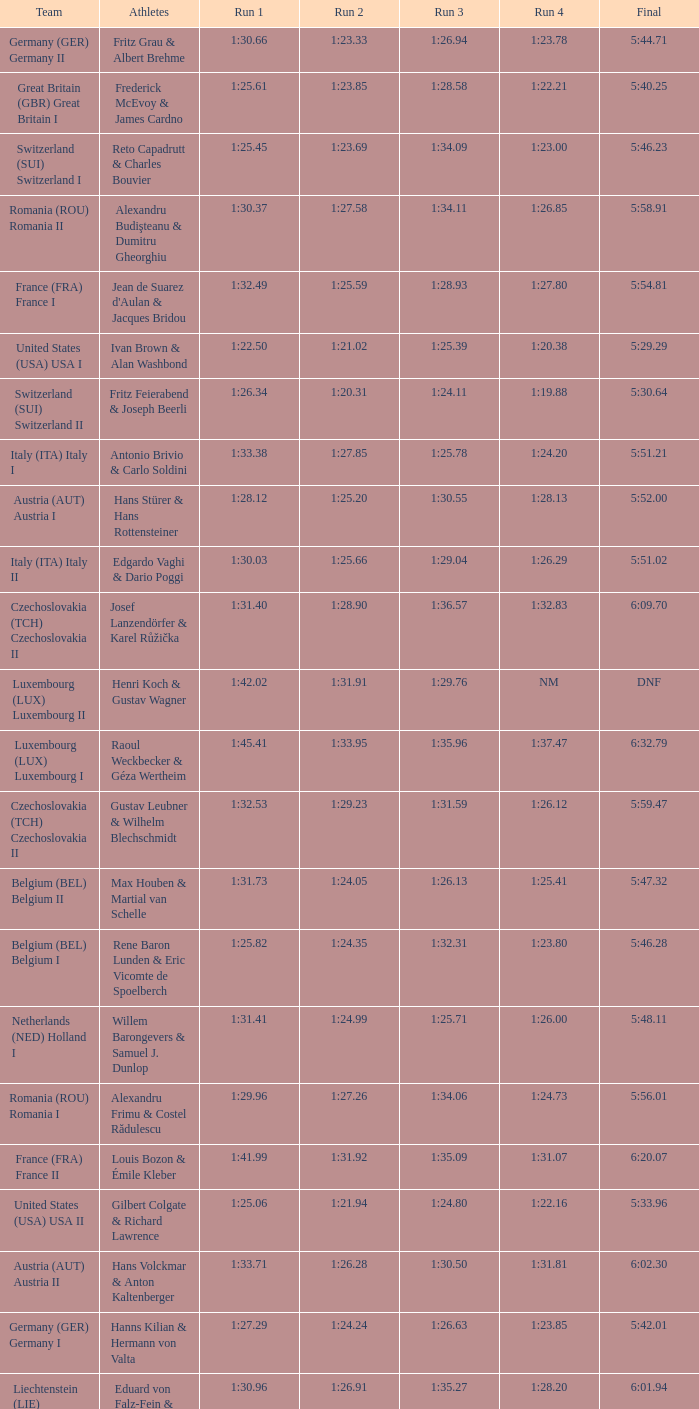Which Run 2 has a Run 1 of 1:30.03? 1:25.66. 